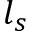Convert formula to latex. <formula><loc_0><loc_0><loc_500><loc_500>l _ { s }</formula> 